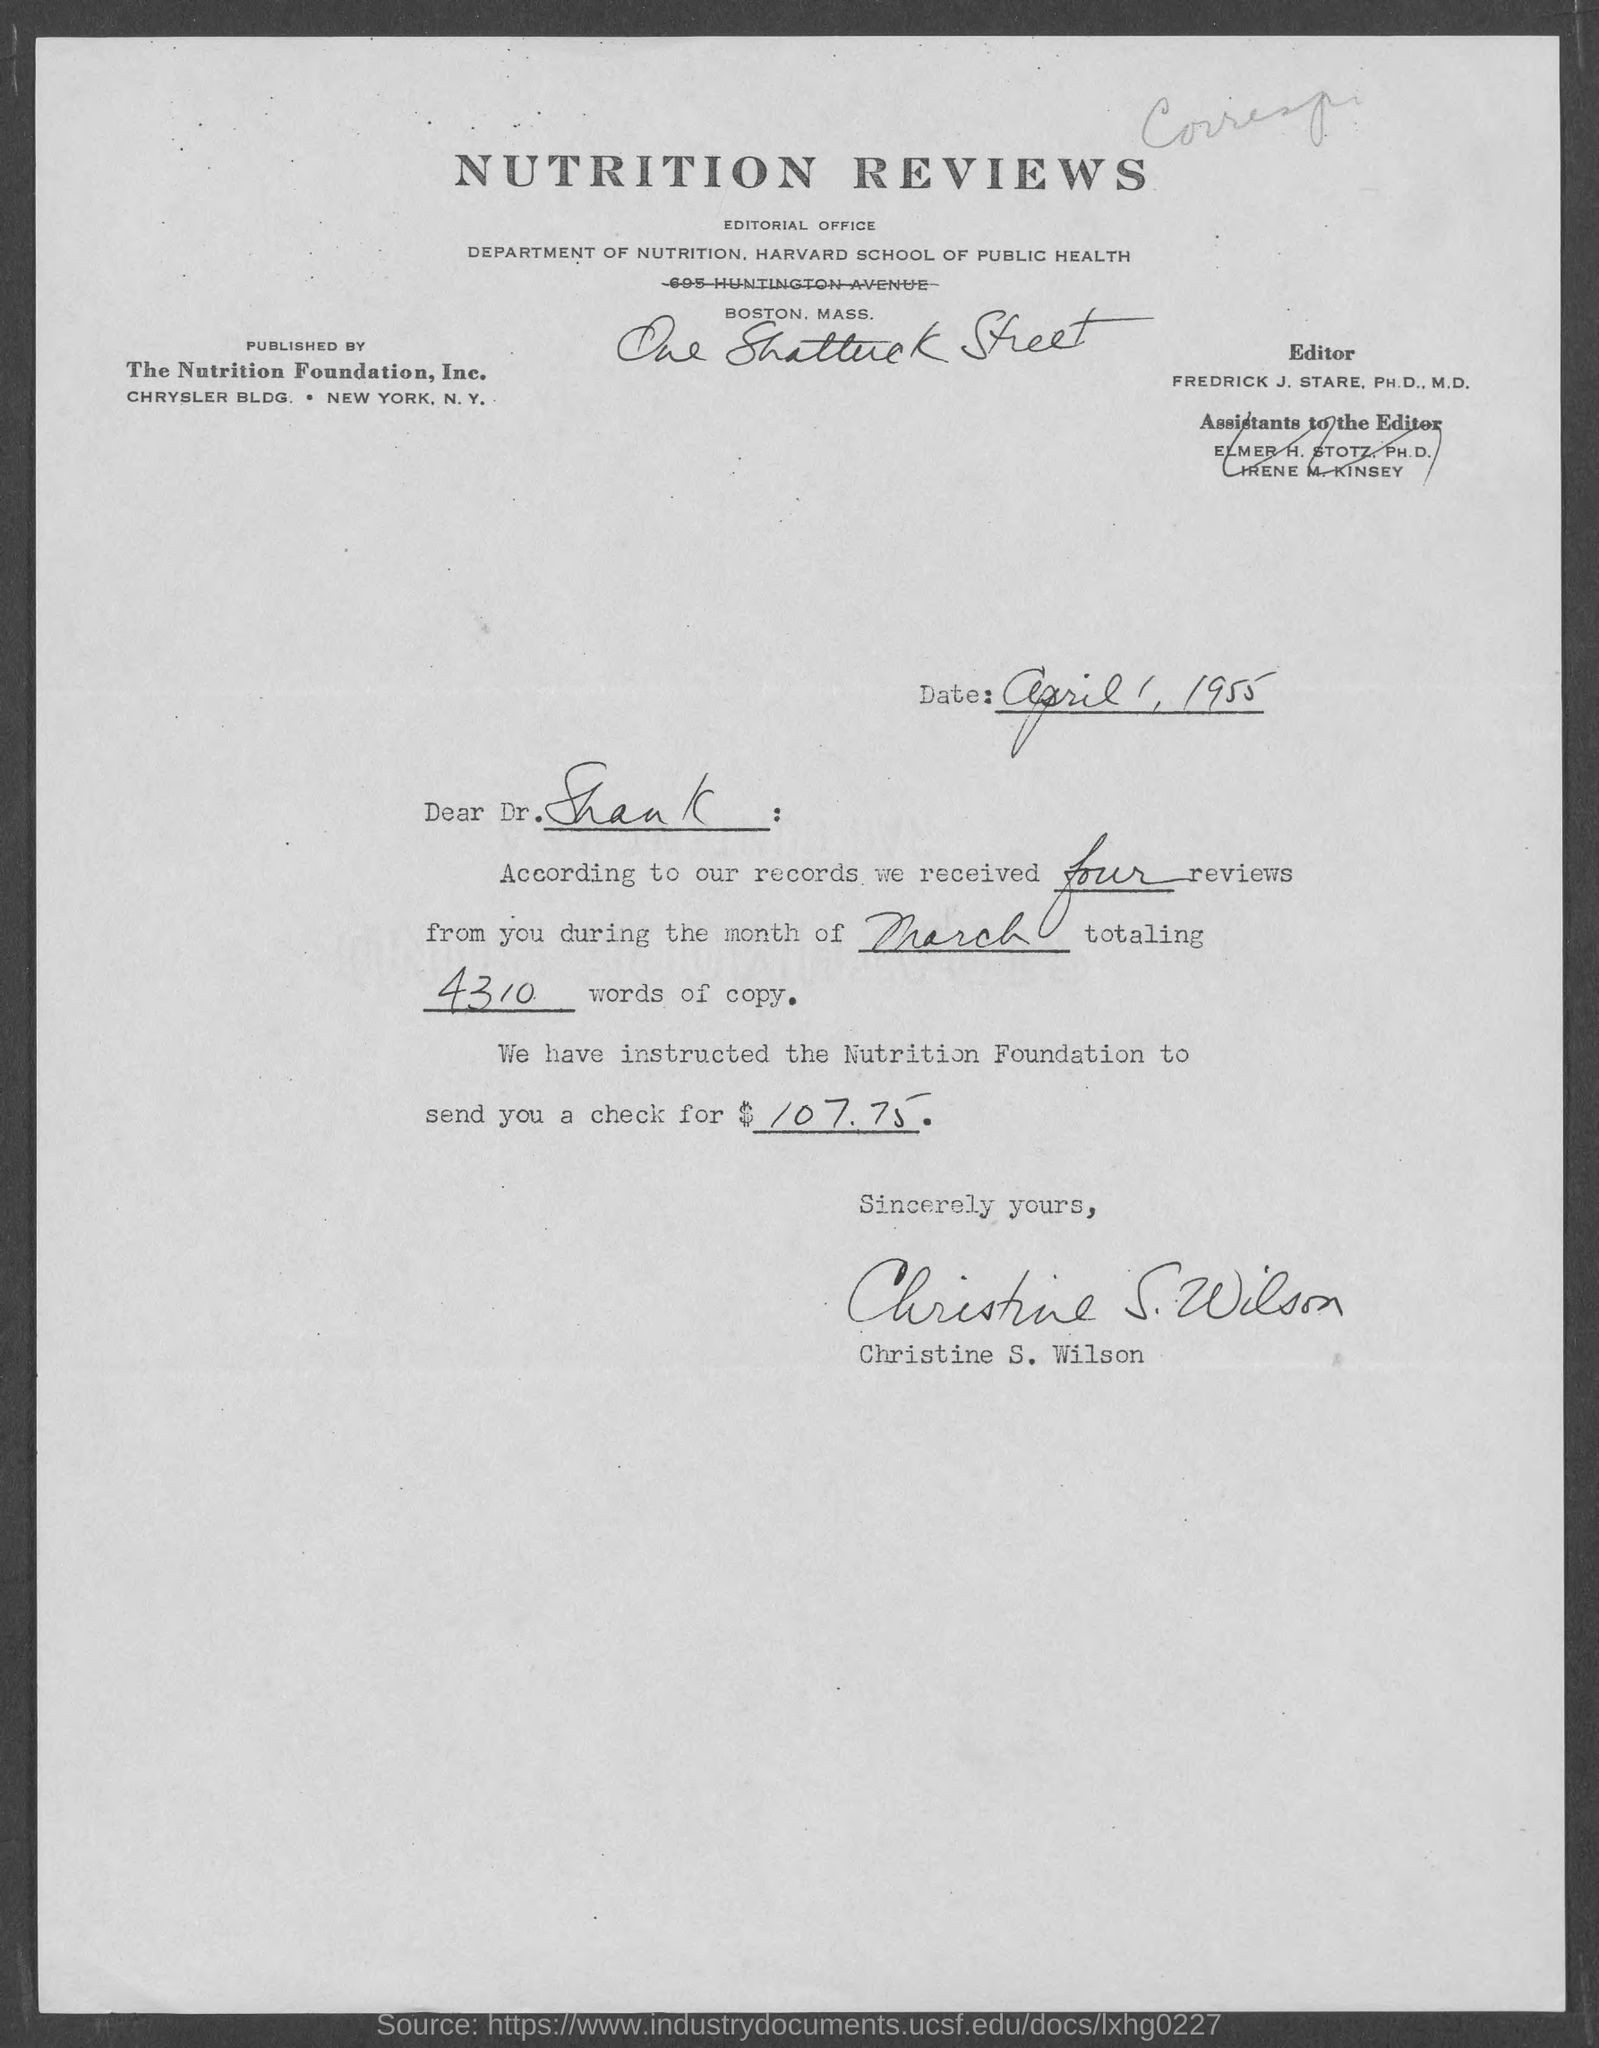Point out several critical features in this image. The letter is written by Christine S. Wilson. April 1, 1955 is the date mentioned. According to our records, we received four reviews from you during the month of March, with a total word count of 4310. This letter is addressed to Dr. Shank. According to their records, they received four reviews. 